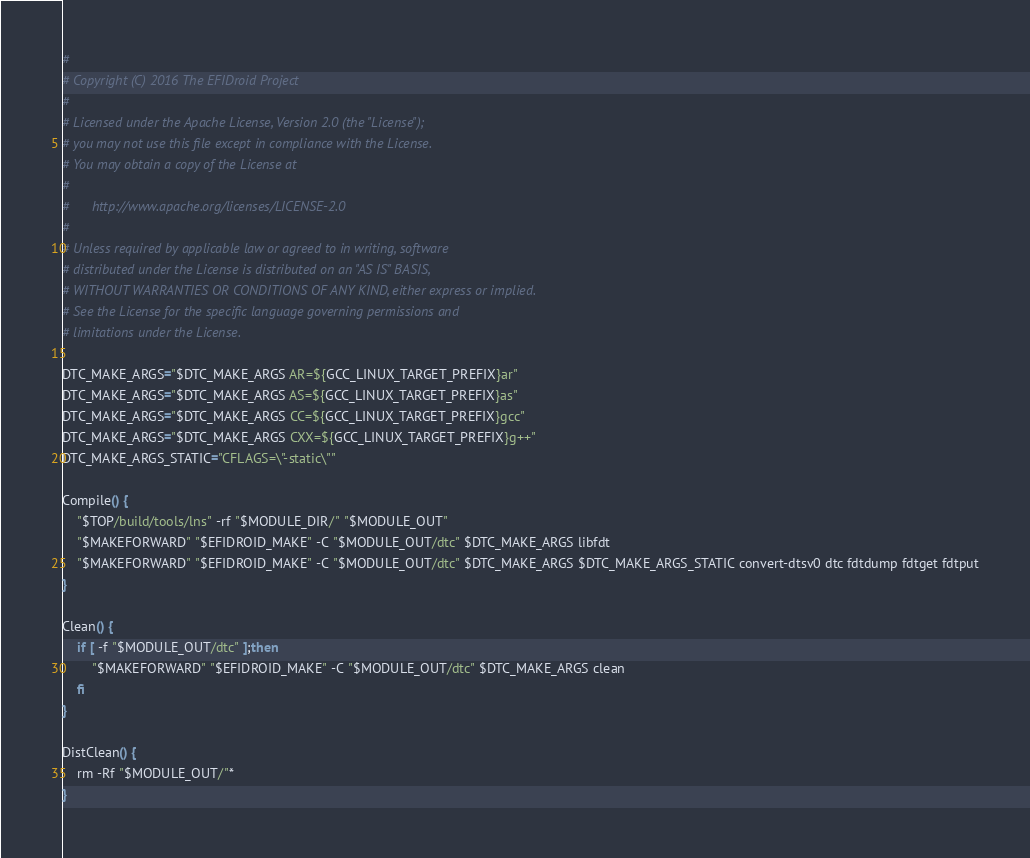<code> <loc_0><loc_0><loc_500><loc_500><_Bash_>#
# Copyright (C) 2016 The EFIDroid Project
#
# Licensed under the Apache License, Version 2.0 (the "License");
# you may not use this file except in compliance with the License.
# You may obtain a copy of the License at
#
#      http://www.apache.org/licenses/LICENSE-2.0
#
# Unless required by applicable law or agreed to in writing, software
# distributed under the License is distributed on an "AS IS" BASIS,
# WITHOUT WARRANTIES OR CONDITIONS OF ANY KIND, either express or implied.
# See the License for the specific language governing permissions and
# limitations under the License.

DTC_MAKE_ARGS="$DTC_MAKE_ARGS AR=${GCC_LINUX_TARGET_PREFIX}ar"
DTC_MAKE_ARGS="$DTC_MAKE_ARGS AS=${GCC_LINUX_TARGET_PREFIX}as"
DTC_MAKE_ARGS="$DTC_MAKE_ARGS CC=${GCC_LINUX_TARGET_PREFIX}gcc"
DTC_MAKE_ARGS="$DTC_MAKE_ARGS CXX=${GCC_LINUX_TARGET_PREFIX}g++"
DTC_MAKE_ARGS_STATIC="CFLAGS=\"-static\""

Compile() {
    "$TOP/build/tools/lns" -rf "$MODULE_DIR/" "$MODULE_OUT"
    "$MAKEFORWARD" "$EFIDROID_MAKE" -C "$MODULE_OUT/dtc" $DTC_MAKE_ARGS libfdt
    "$MAKEFORWARD" "$EFIDROID_MAKE" -C "$MODULE_OUT/dtc" $DTC_MAKE_ARGS $DTC_MAKE_ARGS_STATIC convert-dtsv0 dtc fdtdump fdtget fdtput
}

Clean() {
    if [ -f "$MODULE_OUT/dtc" ];then 
        "$MAKEFORWARD" "$EFIDROID_MAKE" -C "$MODULE_OUT/dtc" $DTC_MAKE_ARGS clean
    fi
}

DistClean() {
    rm -Rf "$MODULE_OUT/"*
}
</code> 